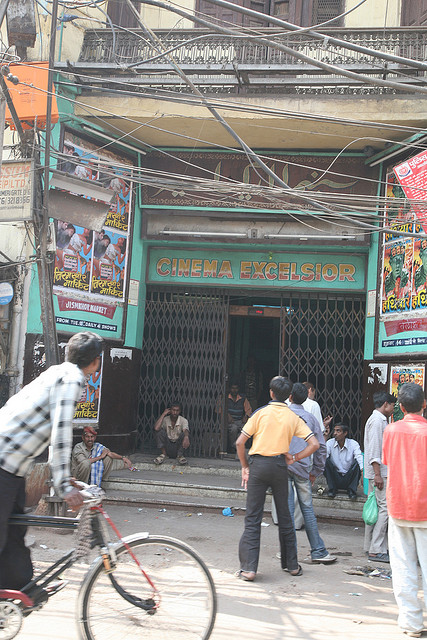What kinds of movies might be shown at this cinema? Given the vibrant and numerous posters on the exterior walls, it appears that 'CINEMA EXCELSIOR' probably showcases a variety of films, ranging from local hits to popular mainstream movies. The colorful and dynamic nature of the posters suggests that the cinema caters to a diverse audience, possibly including action-packed films, comedies, and dramas that appeal to a broad spectrum of the local population. Do the posters give any clues to the popular genres here? Yes, the posters seem to depict lively and energetic scenes typical of action and comedy genres. The use of bright, eye-catching colors and bold fonts indicates a focus on films that promise entertainment and high energy. This suggests that action-packed movies, comedies, and possibly dramatic narratives that draw attention through vibrant visuals are popular choices at this cinema. 